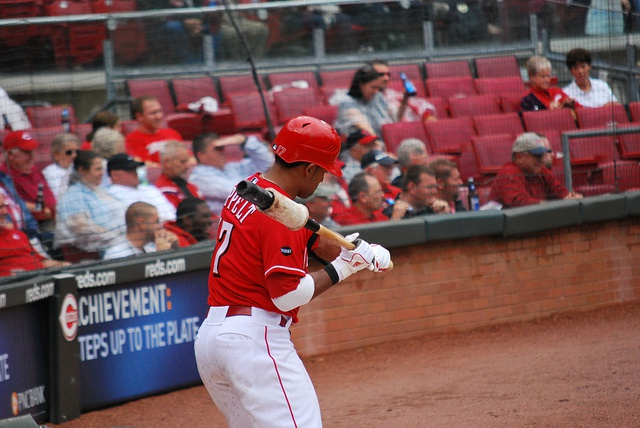Describe the objects in this image and their specific colors. I can see people in maroon, black, gray, and brown tones, people in maroon, lavender, brown, and darkgray tones, people in maroon, darkgray, lightblue, gray, and black tones, people in maroon, brown, darkgray, and lavender tones, and people in maroon, brown, black, and gray tones in this image. 